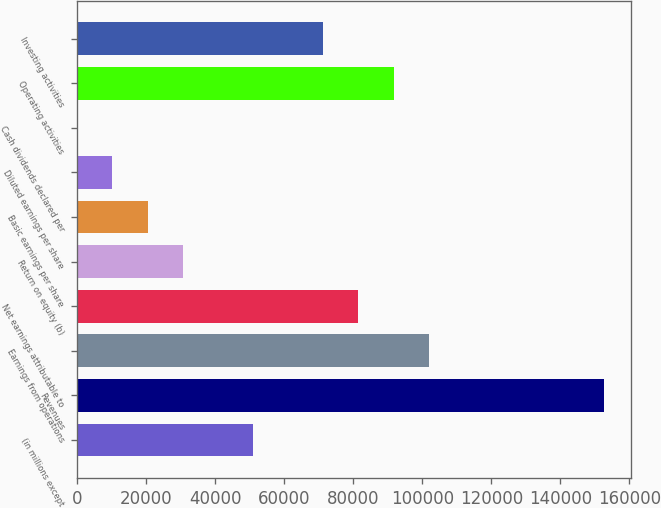Convert chart. <chart><loc_0><loc_0><loc_500><loc_500><bar_chart><fcel>(in millions except<fcel>Revenues<fcel>Earnings from operations<fcel>Net earnings attributable to<fcel>Return on equity (b)<fcel>Basic earnings per share<fcel>Diluted earnings per share<fcel>Cash dividends declared per<fcel>Operating activities<fcel>Investing activities<nl><fcel>50931.3<fcel>152793<fcel>101862<fcel>81489.7<fcel>30559<fcel>20372.9<fcel>10186.8<fcel>0.61<fcel>91675.9<fcel>71303.6<nl></chart> 